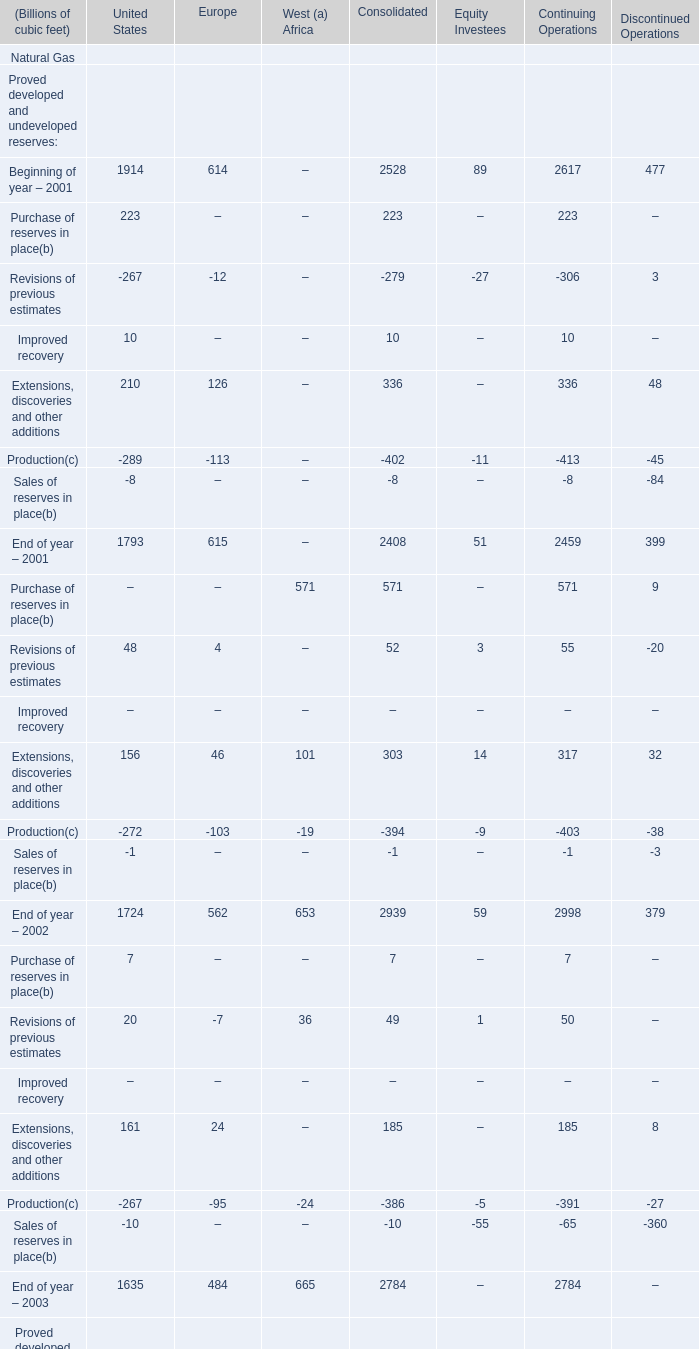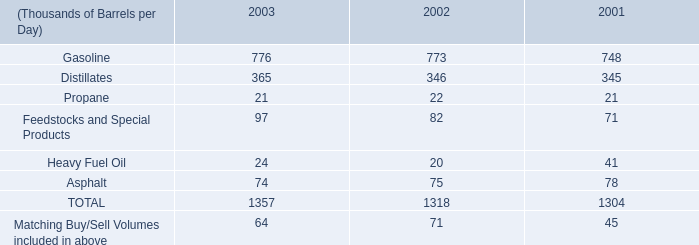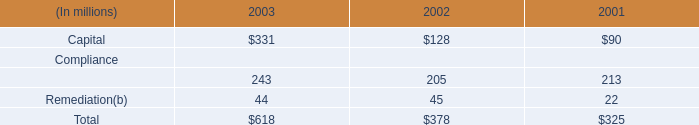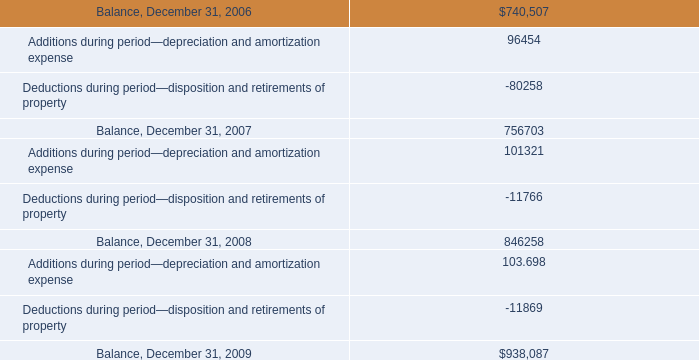What is the sum of End of year – 2002 of United States, and Deductions during period—disposition and retirements of property ? 
Computations: (1724.0 + 11869.0)
Answer: 13593.0. 